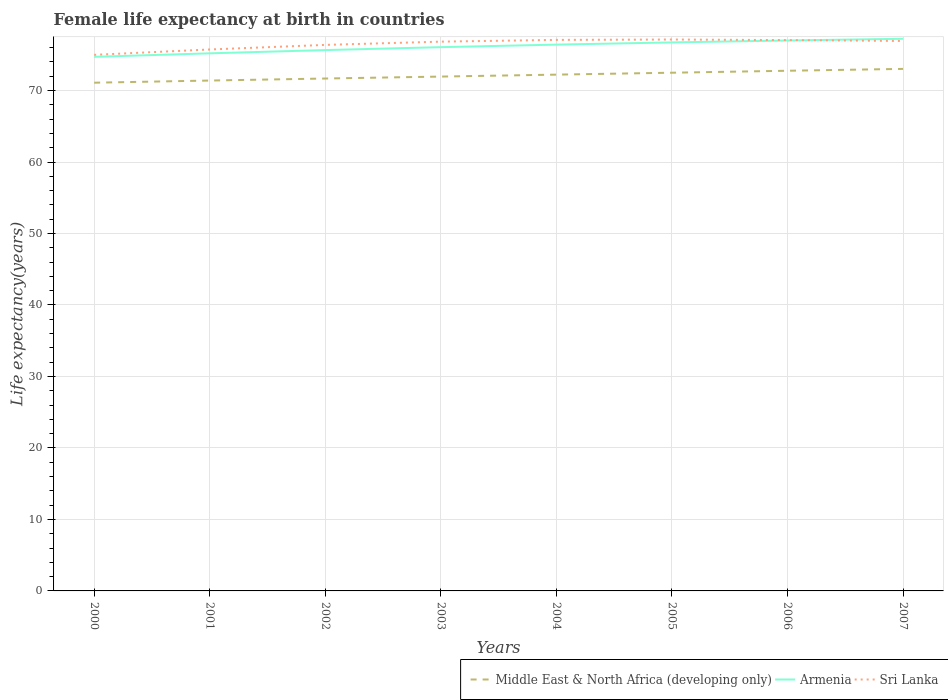How many different coloured lines are there?
Make the answer very short. 3. Does the line corresponding to Sri Lanka intersect with the line corresponding to Armenia?
Your answer should be very brief. Yes. Is the number of lines equal to the number of legend labels?
Give a very brief answer. Yes. Across all years, what is the maximum female life expectancy at birth in Sri Lanka?
Your response must be concise. 75. In which year was the female life expectancy at birth in Middle East & North Africa (developing only) maximum?
Your answer should be very brief. 2000. What is the total female life expectancy at birth in Armenia in the graph?
Make the answer very short. -0.57. What is the difference between the highest and the second highest female life expectancy at birth in Sri Lanka?
Make the answer very short. 2.14. What is the difference between the highest and the lowest female life expectancy at birth in Armenia?
Provide a short and direct response. 4. How many years are there in the graph?
Your response must be concise. 8. Are the values on the major ticks of Y-axis written in scientific E-notation?
Provide a short and direct response. No. Does the graph contain any zero values?
Provide a short and direct response. No. Does the graph contain grids?
Offer a terse response. Yes. How many legend labels are there?
Provide a succinct answer. 3. What is the title of the graph?
Keep it short and to the point. Female life expectancy at birth in countries. What is the label or title of the X-axis?
Ensure brevity in your answer.  Years. What is the label or title of the Y-axis?
Give a very brief answer. Life expectancy(years). What is the Life expectancy(years) of Middle East & North Africa (developing only) in 2000?
Offer a very short reply. 71.1. What is the Life expectancy(years) in Armenia in 2000?
Your response must be concise. 74.72. What is the Life expectancy(years) in Sri Lanka in 2000?
Offer a very short reply. 75. What is the Life expectancy(years) of Middle East & North Africa (developing only) in 2001?
Your answer should be compact. 71.4. What is the Life expectancy(years) in Armenia in 2001?
Your answer should be compact. 75.21. What is the Life expectancy(years) in Sri Lanka in 2001?
Provide a succinct answer. 75.75. What is the Life expectancy(years) of Middle East & North Africa (developing only) in 2002?
Ensure brevity in your answer.  71.68. What is the Life expectancy(years) of Armenia in 2002?
Offer a terse response. 75.66. What is the Life expectancy(years) in Sri Lanka in 2002?
Your response must be concise. 76.39. What is the Life expectancy(years) in Middle East & North Africa (developing only) in 2003?
Make the answer very short. 71.96. What is the Life expectancy(years) of Armenia in 2003?
Provide a short and direct response. 76.07. What is the Life expectancy(years) in Sri Lanka in 2003?
Provide a succinct answer. 76.84. What is the Life expectancy(years) of Middle East & North Africa (developing only) in 2004?
Your answer should be very brief. 72.23. What is the Life expectancy(years) in Armenia in 2004?
Make the answer very short. 76.43. What is the Life expectancy(years) in Sri Lanka in 2004?
Ensure brevity in your answer.  77.09. What is the Life expectancy(years) of Middle East & North Africa (developing only) in 2005?
Ensure brevity in your answer.  72.5. What is the Life expectancy(years) of Armenia in 2005?
Your response must be concise. 76.74. What is the Life expectancy(years) of Sri Lanka in 2005?
Your response must be concise. 77.14. What is the Life expectancy(years) in Middle East & North Africa (developing only) in 2006?
Your answer should be compact. 72.77. What is the Life expectancy(years) of Armenia in 2006?
Offer a very short reply. 77. What is the Life expectancy(years) in Sri Lanka in 2006?
Offer a very short reply. 77.06. What is the Life expectancy(years) in Middle East & North Africa (developing only) in 2007?
Your answer should be compact. 73.03. What is the Life expectancy(years) in Armenia in 2007?
Offer a very short reply. 77.24. What is the Life expectancy(years) of Sri Lanka in 2007?
Your response must be concise. 76.94. Across all years, what is the maximum Life expectancy(years) in Middle East & North Africa (developing only)?
Provide a succinct answer. 73.03. Across all years, what is the maximum Life expectancy(years) in Armenia?
Your answer should be compact. 77.24. Across all years, what is the maximum Life expectancy(years) of Sri Lanka?
Your answer should be very brief. 77.14. Across all years, what is the minimum Life expectancy(years) in Middle East & North Africa (developing only)?
Provide a succinct answer. 71.1. Across all years, what is the minimum Life expectancy(years) of Armenia?
Your response must be concise. 74.72. Across all years, what is the minimum Life expectancy(years) of Sri Lanka?
Make the answer very short. 75. What is the total Life expectancy(years) in Middle East & North Africa (developing only) in the graph?
Ensure brevity in your answer.  576.66. What is the total Life expectancy(years) of Armenia in the graph?
Your response must be concise. 609.07. What is the total Life expectancy(years) of Sri Lanka in the graph?
Provide a succinct answer. 612.19. What is the difference between the Life expectancy(years) of Middle East & North Africa (developing only) in 2000 and that in 2001?
Offer a terse response. -0.3. What is the difference between the Life expectancy(years) in Armenia in 2000 and that in 2001?
Your answer should be very brief. -0.49. What is the difference between the Life expectancy(years) of Sri Lanka in 2000 and that in 2001?
Make the answer very short. -0.75. What is the difference between the Life expectancy(years) in Middle East & North Africa (developing only) in 2000 and that in 2002?
Your answer should be compact. -0.59. What is the difference between the Life expectancy(years) of Armenia in 2000 and that in 2002?
Give a very brief answer. -0.94. What is the difference between the Life expectancy(years) of Sri Lanka in 2000 and that in 2002?
Offer a very short reply. -1.39. What is the difference between the Life expectancy(years) of Middle East & North Africa (developing only) in 2000 and that in 2003?
Provide a short and direct response. -0.86. What is the difference between the Life expectancy(years) of Armenia in 2000 and that in 2003?
Your response must be concise. -1.35. What is the difference between the Life expectancy(years) in Sri Lanka in 2000 and that in 2003?
Your response must be concise. -1.85. What is the difference between the Life expectancy(years) in Middle East & North Africa (developing only) in 2000 and that in 2004?
Offer a very short reply. -1.13. What is the difference between the Life expectancy(years) of Armenia in 2000 and that in 2004?
Provide a short and direct response. -1.71. What is the difference between the Life expectancy(years) in Sri Lanka in 2000 and that in 2004?
Keep it short and to the point. -2.09. What is the difference between the Life expectancy(years) of Middle East & North Africa (developing only) in 2000 and that in 2005?
Make the answer very short. -1.4. What is the difference between the Life expectancy(years) of Armenia in 2000 and that in 2005?
Give a very brief answer. -2.02. What is the difference between the Life expectancy(years) of Sri Lanka in 2000 and that in 2005?
Your answer should be compact. -2.15. What is the difference between the Life expectancy(years) in Middle East & North Africa (developing only) in 2000 and that in 2006?
Your answer should be compact. -1.67. What is the difference between the Life expectancy(years) of Armenia in 2000 and that in 2006?
Offer a terse response. -2.29. What is the difference between the Life expectancy(years) of Sri Lanka in 2000 and that in 2006?
Provide a short and direct response. -2.06. What is the difference between the Life expectancy(years) of Middle East & North Africa (developing only) in 2000 and that in 2007?
Your answer should be very brief. -1.93. What is the difference between the Life expectancy(years) in Armenia in 2000 and that in 2007?
Offer a terse response. -2.53. What is the difference between the Life expectancy(years) of Sri Lanka in 2000 and that in 2007?
Ensure brevity in your answer.  -1.94. What is the difference between the Life expectancy(years) in Middle East & North Africa (developing only) in 2001 and that in 2002?
Give a very brief answer. -0.28. What is the difference between the Life expectancy(years) of Armenia in 2001 and that in 2002?
Keep it short and to the point. -0.46. What is the difference between the Life expectancy(years) of Sri Lanka in 2001 and that in 2002?
Provide a succinct answer. -0.64. What is the difference between the Life expectancy(years) of Middle East & North Africa (developing only) in 2001 and that in 2003?
Ensure brevity in your answer.  -0.56. What is the difference between the Life expectancy(years) in Armenia in 2001 and that in 2003?
Ensure brevity in your answer.  -0.86. What is the difference between the Life expectancy(years) in Sri Lanka in 2001 and that in 2003?
Your response must be concise. -1.1. What is the difference between the Life expectancy(years) of Middle East & North Africa (developing only) in 2001 and that in 2004?
Make the answer very short. -0.83. What is the difference between the Life expectancy(years) of Armenia in 2001 and that in 2004?
Provide a short and direct response. -1.22. What is the difference between the Life expectancy(years) of Sri Lanka in 2001 and that in 2004?
Your answer should be very brief. -1.34. What is the difference between the Life expectancy(years) of Middle East & North Africa (developing only) in 2001 and that in 2005?
Provide a short and direct response. -1.1. What is the difference between the Life expectancy(years) of Armenia in 2001 and that in 2005?
Keep it short and to the point. -1.53. What is the difference between the Life expectancy(years) in Sri Lanka in 2001 and that in 2005?
Your answer should be very brief. -1.39. What is the difference between the Life expectancy(years) in Middle East & North Africa (developing only) in 2001 and that in 2006?
Make the answer very short. -1.37. What is the difference between the Life expectancy(years) of Armenia in 2001 and that in 2006?
Offer a terse response. -1.79. What is the difference between the Life expectancy(years) of Sri Lanka in 2001 and that in 2006?
Your response must be concise. -1.31. What is the difference between the Life expectancy(years) of Middle East & North Africa (developing only) in 2001 and that in 2007?
Ensure brevity in your answer.  -1.63. What is the difference between the Life expectancy(years) in Armenia in 2001 and that in 2007?
Ensure brevity in your answer.  -2.04. What is the difference between the Life expectancy(years) of Sri Lanka in 2001 and that in 2007?
Provide a short and direct response. -1.19. What is the difference between the Life expectancy(years) of Middle East & North Africa (developing only) in 2002 and that in 2003?
Ensure brevity in your answer.  -0.27. What is the difference between the Life expectancy(years) of Armenia in 2002 and that in 2003?
Offer a very short reply. -0.41. What is the difference between the Life expectancy(years) in Sri Lanka in 2002 and that in 2003?
Keep it short and to the point. -0.46. What is the difference between the Life expectancy(years) of Middle East & North Africa (developing only) in 2002 and that in 2004?
Your response must be concise. -0.54. What is the difference between the Life expectancy(years) in Armenia in 2002 and that in 2004?
Your response must be concise. -0.77. What is the difference between the Life expectancy(years) of Sri Lanka in 2002 and that in 2004?
Your answer should be compact. -0.7. What is the difference between the Life expectancy(years) in Middle East & North Africa (developing only) in 2002 and that in 2005?
Keep it short and to the point. -0.81. What is the difference between the Life expectancy(years) in Armenia in 2002 and that in 2005?
Make the answer very short. -1.07. What is the difference between the Life expectancy(years) in Sri Lanka in 2002 and that in 2005?
Your response must be concise. -0.75. What is the difference between the Life expectancy(years) of Middle East & North Africa (developing only) in 2002 and that in 2006?
Offer a terse response. -1.09. What is the difference between the Life expectancy(years) in Armenia in 2002 and that in 2006?
Your response must be concise. -1.34. What is the difference between the Life expectancy(years) of Sri Lanka in 2002 and that in 2006?
Make the answer very short. -0.67. What is the difference between the Life expectancy(years) in Middle East & North Africa (developing only) in 2002 and that in 2007?
Offer a very short reply. -1.35. What is the difference between the Life expectancy(years) in Armenia in 2002 and that in 2007?
Your response must be concise. -1.58. What is the difference between the Life expectancy(years) in Sri Lanka in 2002 and that in 2007?
Offer a very short reply. -0.55. What is the difference between the Life expectancy(years) of Middle East & North Africa (developing only) in 2003 and that in 2004?
Keep it short and to the point. -0.27. What is the difference between the Life expectancy(years) in Armenia in 2003 and that in 2004?
Make the answer very short. -0.36. What is the difference between the Life expectancy(years) in Sri Lanka in 2003 and that in 2004?
Keep it short and to the point. -0.24. What is the difference between the Life expectancy(years) of Middle East & North Africa (developing only) in 2003 and that in 2005?
Your answer should be compact. -0.54. What is the difference between the Life expectancy(years) of Armenia in 2003 and that in 2005?
Make the answer very short. -0.67. What is the difference between the Life expectancy(years) in Sri Lanka in 2003 and that in 2005?
Make the answer very short. -0.3. What is the difference between the Life expectancy(years) of Middle East & North Africa (developing only) in 2003 and that in 2006?
Offer a very short reply. -0.81. What is the difference between the Life expectancy(years) of Armenia in 2003 and that in 2006?
Provide a short and direct response. -0.93. What is the difference between the Life expectancy(years) in Sri Lanka in 2003 and that in 2006?
Your response must be concise. -0.21. What is the difference between the Life expectancy(years) in Middle East & North Africa (developing only) in 2003 and that in 2007?
Make the answer very short. -1.08. What is the difference between the Life expectancy(years) of Armenia in 2003 and that in 2007?
Give a very brief answer. -1.17. What is the difference between the Life expectancy(years) of Sri Lanka in 2003 and that in 2007?
Keep it short and to the point. -0.09. What is the difference between the Life expectancy(years) of Middle East & North Africa (developing only) in 2004 and that in 2005?
Keep it short and to the point. -0.27. What is the difference between the Life expectancy(years) in Armenia in 2004 and that in 2005?
Ensure brevity in your answer.  -0.31. What is the difference between the Life expectancy(years) in Sri Lanka in 2004 and that in 2005?
Your answer should be compact. -0.05. What is the difference between the Life expectancy(years) of Middle East & North Africa (developing only) in 2004 and that in 2006?
Your answer should be compact. -0.54. What is the difference between the Life expectancy(years) of Armenia in 2004 and that in 2006?
Offer a terse response. -0.57. What is the difference between the Life expectancy(years) in Sri Lanka in 2004 and that in 2006?
Keep it short and to the point. 0.03. What is the difference between the Life expectancy(years) of Middle East & North Africa (developing only) in 2004 and that in 2007?
Provide a succinct answer. -0.8. What is the difference between the Life expectancy(years) in Armenia in 2004 and that in 2007?
Provide a succinct answer. -0.82. What is the difference between the Life expectancy(years) of Middle East & North Africa (developing only) in 2005 and that in 2006?
Offer a terse response. -0.27. What is the difference between the Life expectancy(years) of Armenia in 2005 and that in 2006?
Provide a succinct answer. -0.27. What is the difference between the Life expectancy(years) of Sri Lanka in 2005 and that in 2006?
Provide a short and direct response. 0.08. What is the difference between the Life expectancy(years) in Middle East & North Africa (developing only) in 2005 and that in 2007?
Your response must be concise. -0.54. What is the difference between the Life expectancy(years) of Armenia in 2005 and that in 2007?
Give a very brief answer. -0.51. What is the difference between the Life expectancy(years) of Sri Lanka in 2005 and that in 2007?
Make the answer very short. 0.2. What is the difference between the Life expectancy(years) of Middle East & North Africa (developing only) in 2006 and that in 2007?
Provide a short and direct response. -0.26. What is the difference between the Life expectancy(years) in Armenia in 2006 and that in 2007?
Your answer should be compact. -0.24. What is the difference between the Life expectancy(years) in Sri Lanka in 2006 and that in 2007?
Your response must be concise. 0.12. What is the difference between the Life expectancy(years) in Middle East & North Africa (developing only) in 2000 and the Life expectancy(years) in Armenia in 2001?
Provide a succinct answer. -4.11. What is the difference between the Life expectancy(years) of Middle East & North Africa (developing only) in 2000 and the Life expectancy(years) of Sri Lanka in 2001?
Your answer should be very brief. -4.65. What is the difference between the Life expectancy(years) of Armenia in 2000 and the Life expectancy(years) of Sri Lanka in 2001?
Ensure brevity in your answer.  -1.03. What is the difference between the Life expectancy(years) in Middle East & North Africa (developing only) in 2000 and the Life expectancy(years) in Armenia in 2002?
Ensure brevity in your answer.  -4.56. What is the difference between the Life expectancy(years) in Middle East & North Africa (developing only) in 2000 and the Life expectancy(years) in Sri Lanka in 2002?
Offer a very short reply. -5.29. What is the difference between the Life expectancy(years) in Armenia in 2000 and the Life expectancy(years) in Sri Lanka in 2002?
Give a very brief answer. -1.67. What is the difference between the Life expectancy(years) of Middle East & North Africa (developing only) in 2000 and the Life expectancy(years) of Armenia in 2003?
Offer a terse response. -4.97. What is the difference between the Life expectancy(years) of Middle East & North Africa (developing only) in 2000 and the Life expectancy(years) of Sri Lanka in 2003?
Your response must be concise. -5.74. What is the difference between the Life expectancy(years) in Armenia in 2000 and the Life expectancy(years) in Sri Lanka in 2003?
Provide a short and direct response. -2.13. What is the difference between the Life expectancy(years) of Middle East & North Africa (developing only) in 2000 and the Life expectancy(years) of Armenia in 2004?
Make the answer very short. -5.33. What is the difference between the Life expectancy(years) in Middle East & North Africa (developing only) in 2000 and the Life expectancy(years) in Sri Lanka in 2004?
Offer a very short reply. -5.99. What is the difference between the Life expectancy(years) of Armenia in 2000 and the Life expectancy(years) of Sri Lanka in 2004?
Your answer should be very brief. -2.37. What is the difference between the Life expectancy(years) of Middle East & North Africa (developing only) in 2000 and the Life expectancy(years) of Armenia in 2005?
Your answer should be very brief. -5.64. What is the difference between the Life expectancy(years) of Middle East & North Africa (developing only) in 2000 and the Life expectancy(years) of Sri Lanka in 2005?
Your answer should be compact. -6.04. What is the difference between the Life expectancy(years) of Armenia in 2000 and the Life expectancy(years) of Sri Lanka in 2005?
Keep it short and to the point. -2.42. What is the difference between the Life expectancy(years) in Middle East & North Africa (developing only) in 2000 and the Life expectancy(years) in Armenia in 2006?
Provide a succinct answer. -5.9. What is the difference between the Life expectancy(years) of Middle East & North Africa (developing only) in 2000 and the Life expectancy(years) of Sri Lanka in 2006?
Make the answer very short. -5.96. What is the difference between the Life expectancy(years) in Armenia in 2000 and the Life expectancy(years) in Sri Lanka in 2006?
Provide a succinct answer. -2.34. What is the difference between the Life expectancy(years) of Middle East & North Africa (developing only) in 2000 and the Life expectancy(years) of Armenia in 2007?
Keep it short and to the point. -6.14. What is the difference between the Life expectancy(years) of Middle East & North Africa (developing only) in 2000 and the Life expectancy(years) of Sri Lanka in 2007?
Offer a terse response. -5.84. What is the difference between the Life expectancy(years) of Armenia in 2000 and the Life expectancy(years) of Sri Lanka in 2007?
Give a very brief answer. -2.22. What is the difference between the Life expectancy(years) of Middle East & North Africa (developing only) in 2001 and the Life expectancy(years) of Armenia in 2002?
Give a very brief answer. -4.26. What is the difference between the Life expectancy(years) in Middle East & North Africa (developing only) in 2001 and the Life expectancy(years) in Sri Lanka in 2002?
Your response must be concise. -4.99. What is the difference between the Life expectancy(years) of Armenia in 2001 and the Life expectancy(years) of Sri Lanka in 2002?
Your answer should be compact. -1.18. What is the difference between the Life expectancy(years) of Middle East & North Africa (developing only) in 2001 and the Life expectancy(years) of Armenia in 2003?
Offer a very short reply. -4.67. What is the difference between the Life expectancy(years) in Middle East & North Africa (developing only) in 2001 and the Life expectancy(years) in Sri Lanka in 2003?
Provide a succinct answer. -5.44. What is the difference between the Life expectancy(years) of Armenia in 2001 and the Life expectancy(years) of Sri Lanka in 2003?
Your answer should be very brief. -1.64. What is the difference between the Life expectancy(years) in Middle East & North Africa (developing only) in 2001 and the Life expectancy(years) in Armenia in 2004?
Your answer should be compact. -5.03. What is the difference between the Life expectancy(years) in Middle East & North Africa (developing only) in 2001 and the Life expectancy(years) in Sri Lanka in 2004?
Your answer should be compact. -5.69. What is the difference between the Life expectancy(years) in Armenia in 2001 and the Life expectancy(years) in Sri Lanka in 2004?
Provide a succinct answer. -1.88. What is the difference between the Life expectancy(years) in Middle East & North Africa (developing only) in 2001 and the Life expectancy(years) in Armenia in 2005?
Your answer should be very brief. -5.34. What is the difference between the Life expectancy(years) in Middle East & North Africa (developing only) in 2001 and the Life expectancy(years) in Sri Lanka in 2005?
Your answer should be very brief. -5.74. What is the difference between the Life expectancy(years) in Armenia in 2001 and the Life expectancy(years) in Sri Lanka in 2005?
Provide a succinct answer. -1.93. What is the difference between the Life expectancy(years) of Middle East & North Africa (developing only) in 2001 and the Life expectancy(years) of Armenia in 2006?
Offer a very short reply. -5.6. What is the difference between the Life expectancy(years) in Middle East & North Africa (developing only) in 2001 and the Life expectancy(years) in Sri Lanka in 2006?
Ensure brevity in your answer.  -5.66. What is the difference between the Life expectancy(years) in Armenia in 2001 and the Life expectancy(years) in Sri Lanka in 2006?
Offer a very short reply. -1.85. What is the difference between the Life expectancy(years) in Middle East & North Africa (developing only) in 2001 and the Life expectancy(years) in Armenia in 2007?
Offer a very short reply. -5.84. What is the difference between the Life expectancy(years) of Middle East & North Africa (developing only) in 2001 and the Life expectancy(years) of Sri Lanka in 2007?
Give a very brief answer. -5.54. What is the difference between the Life expectancy(years) in Armenia in 2001 and the Life expectancy(years) in Sri Lanka in 2007?
Make the answer very short. -1.73. What is the difference between the Life expectancy(years) of Middle East & North Africa (developing only) in 2002 and the Life expectancy(years) of Armenia in 2003?
Ensure brevity in your answer.  -4.39. What is the difference between the Life expectancy(years) of Middle East & North Africa (developing only) in 2002 and the Life expectancy(years) of Sri Lanka in 2003?
Your answer should be compact. -5.16. What is the difference between the Life expectancy(years) in Armenia in 2002 and the Life expectancy(years) in Sri Lanka in 2003?
Make the answer very short. -1.18. What is the difference between the Life expectancy(years) of Middle East & North Africa (developing only) in 2002 and the Life expectancy(years) of Armenia in 2004?
Your response must be concise. -4.74. What is the difference between the Life expectancy(years) in Middle East & North Africa (developing only) in 2002 and the Life expectancy(years) in Sri Lanka in 2004?
Give a very brief answer. -5.4. What is the difference between the Life expectancy(years) of Armenia in 2002 and the Life expectancy(years) of Sri Lanka in 2004?
Your answer should be compact. -1.43. What is the difference between the Life expectancy(years) in Middle East & North Africa (developing only) in 2002 and the Life expectancy(years) in Armenia in 2005?
Your response must be concise. -5.05. What is the difference between the Life expectancy(years) of Middle East & North Africa (developing only) in 2002 and the Life expectancy(years) of Sri Lanka in 2005?
Offer a very short reply. -5.46. What is the difference between the Life expectancy(years) in Armenia in 2002 and the Life expectancy(years) in Sri Lanka in 2005?
Give a very brief answer. -1.48. What is the difference between the Life expectancy(years) in Middle East & North Africa (developing only) in 2002 and the Life expectancy(years) in Armenia in 2006?
Give a very brief answer. -5.32. What is the difference between the Life expectancy(years) in Middle East & North Africa (developing only) in 2002 and the Life expectancy(years) in Sri Lanka in 2006?
Keep it short and to the point. -5.37. What is the difference between the Life expectancy(years) in Armenia in 2002 and the Life expectancy(years) in Sri Lanka in 2006?
Your response must be concise. -1.4. What is the difference between the Life expectancy(years) in Middle East & North Africa (developing only) in 2002 and the Life expectancy(years) in Armenia in 2007?
Give a very brief answer. -5.56. What is the difference between the Life expectancy(years) of Middle East & North Africa (developing only) in 2002 and the Life expectancy(years) of Sri Lanka in 2007?
Provide a succinct answer. -5.25. What is the difference between the Life expectancy(years) in Armenia in 2002 and the Life expectancy(years) in Sri Lanka in 2007?
Your answer should be compact. -1.27. What is the difference between the Life expectancy(years) of Middle East & North Africa (developing only) in 2003 and the Life expectancy(years) of Armenia in 2004?
Keep it short and to the point. -4.47. What is the difference between the Life expectancy(years) of Middle East & North Africa (developing only) in 2003 and the Life expectancy(years) of Sri Lanka in 2004?
Offer a terse response. -5.13. What is the difference between the Life expectancy(years) in Armenia in 2003 and the Life expectancy(years) in Sri Lanka in 2004?
Your answer should be very brief. -1.02. What is the difference between the Life expectancy(years) in Middle East & North Africa (developing only) in 2003 and the Life expectancy(years) in Armenia in 2005?
Your answer should be very brief. -4.78. What is the difference between the Life expectancy(years) of Middle East & North Africa (developing only) in 2003 and the Life expectancy(years) of Sri Lanka in 2005?
Your answer should be compact. -5.18. What is the difference between the Life expectancy(years) in Armenia in 2003 and the Life expectancy(years) in Sri Lanka in 2005?
Provide a succinct answer. -1.07. What is the difference between the Life expectancy(years) in Middle East & North Africa (developing only) in 2003 and the Life expectancy(years) in Armenia in 2006?
Offer a very short reply. -5.05. What is the difference between the Life expectancy(years) in Middle East & North Africa (developing only) in 2003 and the Life expectancy(years) in Sri Lanka in 2006?
Your response must be concise. -5.1. What is the difference between the Life expectancy(years) of Armenia in 2003 and the Life expectancy(years) of Sri Lanka in 2006?
Ensure brevity in your answer.  -0.99. What is the difference between the Life expectancy(years) in Middle East & North Africa (developing only) in 2003 and the Life expectancy(years) in Armenia in 2007?
Your answer should be very brief. -5.29. What is the difference between the Life expectancy(years) in Middle East & North Africa (developing only) in 2003 and the Life expectancy(years) in Sri Lanka in 2007?
Your response must be concise. -4.98. What is the difference between the Life expectancy(years) of Armenia in 2003 and the Life expectancy(years) of Sri Lanka in 2007?
Your answer should be very brief. -0.87. What is the difference between the Life expectancy(years) in Middle East & North Africa (developing only) in 2004 and the Life expectancy(years) in Armenia in 2005?
Your response must be concise. -4.51. What is the difference between the Life expectancy(years) of Middle East & North Africa (developing only) in 2004 and the Life expectancy(years) of Sri Lanka in 2005?
Provide a succinct answer. -4.91. What is the difference between the Life expectancy(years) in Armenia in 2004 and the Life expectancy(years) in Sri Lanka in 2005?
Give a very brief answer. -0.71. What is the difference between the Life expectancy(years) of Middle East & North Africa (developing only) in 2004 and the Life expectancy(years) of Armenia in 2006?
Provide a succinct answer. -4.77. What is the difference between the Life expectancy(years) of Middle East & North Africa (developing only) in 2004 and the Life expectancy(years) of Sri Lanka in 2006?
Your answer should be compact. -4.83. What is the difference between the Life expectancy(years) of Armenia in 2004 and the Life expectancy(years) of Sri Lanka in 2006?
Make the answer very short. -0.63. What is the difference between the Life expectancy(years) of Middle East & North Africa (developing only) in 2004 and the Life expectancy(years) of Armenia in 2007?
Give a very brief answer. -5.02. What is the difference between the Life expectancy(years) of Middle East & North Africa (developing only) in 2004 and the Life expectancy(years) of Sri Lanka in 2007?
Your answer should be compact. -4.71. What is the difference between the Life expectancy(years) in Armenia in 2004 and the Life expectancy(years) in Sri Lanka in 2007?
Give a very brief answer. -0.51. What is the difference between the Life expectancy(years) of Middle East & North Africa (developing only) in 2005 and the Life expectancy(years) of Armenia in 2006?
Your answer should be very brief. -4.51. What is the difference between the Life expectancy(years) in Middle East & North Africa (developing only) in 2005 and the Life expectancy(years) in Sri Lanka in 2006?
Ensure brevity in your answer.  -4.56. What is the difference between the Life expectancy(years) of Armenia in 2005 and the Life expectancy(years) of Sri Lanka in 2006?
Make the answer very short. -0.32. What is the difference between the Life expectancy(years) in Middle East & North Africa (developing only) in 2005 and the Life expectancy(years) in Armenia in 2007?
Your answer should be compact. -4.75. What is the difference between the Life expectancy(years) in Middle East & North Africa (developing only) in 2005 and the Life expectancy(years) in Sri Lanka in 2007?
Offer a terse response. -4.44. What is the difference between the Life expectancy(years) of Armenia in 2005 and the Life expectancy(years) of Sri Lanka in 2007?
Give a very brief answer. -0.2. What is the difference between the Life expectancy(years) in Middle East & North Africa (developing only) in 2006 and the Life expectancy(years) in Armenia in 2007?
Offer a very short reply. -4.47. What is the difference between the Life expectancy(years) in Middle East & North Africa (developing only) in 2006 and the Life expectancy(years) in Sri Lanka in 2007?
Ensure brevity in your answer.  -4.17. What is the difference between the Life expectancy(years) in Armenia in 2006 and the Life expectancy(years) in Sri Lanka in 2007?
Ensure brevity in your answer.  0.07. What is the average Life expectancy(years) in Middle East & North Africa (developing only) per year?
Ensure brevity in your answer.  72.08. What is the average Life expectancy(years) in Armenia per year?
Provide a short and direct response. 76.13. What is the average Life expectancy(years) of Sri Lanka per year?
Provide a succinct answer. 76.52. In the year 2000, what is the difference between the Life expectancy(years) in Middle East & North Africa (developing only) and Life expectancy(years) in Armenia?
Give a very brief answer. -3.62. In the year 2000, what is the difference between the Life expectancy(years) of Middle East & North Africa (developing only) and Life expectancy(years) of Sri Lanka?
Give a very brief answer. -3.9. In the year 2000, what is the difference between the Life expectancy(years) of Armenia and Life expectancy(years) of Sri Lanka?
Offer a very short reply. -0.28. In the year 2001, what is the difference between the Life expectancy(years) in Middle East & North Africa (developing only) and Life expectancy(years) in Armenia?
Ensure brevity in your answer.  -3.81. In the year 2001, what is the difference between the Life expectancy(years) of Middle East & North Africa (developing only) and Life expectancy(years) of Sri Lanka?
Ensure brevity in your answer.  -4.35. In the year 2001, what is the difference between the Life expectancy(years) of Armenia and Life expectancy(years) of Sri Lanka?
Keep it short and to the point. -0.54. In the year 2002, what is the difference between the Life expectancy(years) in Middle East & North Africa (developing only) and Life expectancy(years) in Armenia?
Your answer should be very brief. -3.98. In the year 2002, what is the difference between the Life expectancy(years) of Middle East & North Africa (developing only) and Life expectancy(years) of Sri Lanka?
Ensure brevity in your answer.  -4.7. In the year 2002, what is the difference between the Life expectancy(years) in Armenia and Life expectancy(years) in Sri Lanka?
Keep it short and to the point. -0.73. In the year 2003, what is the difference between the Life expectancy(years) in Middle East & North Africa (developing only) and Life expectancy(years) in Armenia?
Offer a very short reply. -4.12. In the year 2003, what is the difference between the Life expectancy(years) of Middle East & North Africa (developing only) and Life expectancy(years) of Sri Lanka?
Ensure brevity in your answer.  -4.89. In the year 2003, what is the difference between the Life expectancy(years) of Armenia and Life expectancy(years) of Sri Lanka?
Give a very brief answer. -0.77. In the year 2004, what is the difference between the Life expectancy(years) in Middle East & North Africa (developing only) and Life expectancy(years) in Armenia?
Provide a short and direct response. -4.2. In the year 2004, what is the difference between the Life expectancy(years) in Middle East & North Africa (developing only) and Life expectancy(years) in Sri Lanka?
Offer a very short reply. -4.86. In the year 2004, what is the difference between the Life expectancy(years) in Armenia and Life expectancy(years) in Sri Lanka?
Give a very brief answer. -0.66. In the year 2005, what is the difference between the Life expectancy(years) in Middle East & North Africa (developing only) and Life expectancy(years) in Armenia?
Your response must be concise. -4.24. In the year 2005, what is the difference between the Life expectancy(years) of Middle East & North Africa (developing only) and Life expectancy(years) of Sri Lanka?
Ensure brevity in your answer.  -4.64. In the year 2005, what is the difference between the Life expectancy(years) in Armenia and Life expectancy(years) in Sri Lanka?
Offer a terse response. -0.4. In the year 2006, what is the difference between the Life expectancy(years) in Middle East & North Africa (developing only) and Life expectancy(years) in Armenia?
Make the answer very short. -4.23. In the year 2006, what is the difference between the Life expectancy(years) in Middle East & North Africa (developing only) and Life expectancy(years) in Sri Lanka?
Offer a terse response. -4.29. In the year 2006, what is the difference between the Life expectancy(years) of Armenia and Life expectancy(years) of Sri Lanka?
Your answer should be very brief. -0.06. In the year 2007, what is the difference between the Life expectancy(years) of Middle East & North Africa (developing only) and Life expectancy(years) of Armenia?
Offer a terse response. -4.21. In the year 2007, what is the difference between the Life expectancy(years) in Middle East & North Africa (developing only) and Life expectancy(years) in Sri Lanka?
Ensure brevity in your answer.  -3.91. In the year 2007, what is the difference between the Life expectancy(years) in Armenia and Life expectancy(years) in Sri Lanka?
Provide a short and direct response. 0.31. What is the ratio of the Life expectancy(years) in Middle East & North Africa (developing only) in 2000 to that in 2001?
Offer a very short reply. 1. What is the ratio of the Life expectancy(years) in Armenia in 2000 to that in 2001?
Your answer should be compact. 0.99. What is the ratio of the Life expectancy(years) in Armenia in 2000 to that in 2002?
Your answer should be compact. 0.99. What is the ratio of the Life expectancy(years) of Sri Lanka in 2000 to that in 2002?
Provide a short and direct response. 0.98. What is the ratio of the Life expectancy(years) in Armenia in 2000 to that in 2003?
Your response must be concise. 0.98. What is the ratio of the Life expectancy(years) of Sri Lanka in 2000 to that in 2003?
Keep it short and to the point. 0.98. What is the ratio of the Life expectancy(years) in Middle East & North Africa (developing only) in 2000 to that in 2004?
Offer a very short reply. 0.98. What is the ratio of the Life expectancy(years) in Armenia in 2000 to that in 2004?
Your answer should be compact. 0.98. What is the ratio of the Life expectancy(years) of Sri Lanka in 2000 to that in 2004?
Give a very brief answer. 0.97. What is the ratio of the Life expectancy(years) of Middle East & North Africa (developing only) in 2000 to that in 2005?
Your response must be concise. 0.98. What is the ratio of the Life expectancy(years) of Armenia in 2000 to that in 2005?
Offer a very short reply. 0.97. What is the ratio of the Life expectancy(years) of Sri Lanka in 2000 to that in 2005?
Offer a terse response. 0.97. What is the ratio of the Life expectancy(years) in Middle East & North Africa (developing only) in 2000 to that in 2006?
Give a very brief answer. 0.98. What is the ratio of the Life expectancy(years) of Armenia in 2000 to that in 2006?
Make the answer very short. 0.97. What is the ratio of the Life expectancy(years) in Sri Lanka in 2000 to that in 2006?
Your response must be concise. 0.97. What is the ratio of the Life expectancy(years) in Middle East & North Africa (developing only) in 2000 to that in 2007?
Offer a very short reply. 0.97. What is the ratio of the Life expectancy(years) in Armenia in 2000 to that in 2007?
Provide a short and direct response. 0.97. What is the ratio of the Life expectancy(years) in Sri Lanka in 2000 to that in 2007?
Your answer should be very brief. 0.97. What is the ratio of the Life expectancy(years) of Middle East & North Africa (developing only) in 2001 to that in 2003?
Your answer should be compact. 0.99. What is the ratio of the Life expectancy(years) of Sri Lanka in 2001 to that in 2003?
Ensure brevity in your answer.  0.99. What is the ratio of the Life expectancy(years) of Armenia in 2001 to that in 2004?
Make the answer very short. 0.98. What is the ratio of the Life expectancy(years) of Sri Lanka in 2001 to that in 2004?
Give a very brief answer. 0.98. What is the ratio of the Life expectancy(years) of Middle East & North Africa (developing only) in 2001 to that in 2005?
Offer a very short reply. 0.98. What is the ratio of the Life expectancy(years) of Armenia in 2001 to that in 2005?
Offer a terse response. 0.98. What is the ratio of the Life expectancy(years) in Sri Lanka in 2001 to that in 2005?
Your answer should be compact. 0.98. What is the ratio of the Life expectancy(years) of Middle East & North Africa (developing only) in 2001 to that in 2006?
Provide a succinct answer. 0.98. What is the ratio of the Life expectancy(years) of Armenia in 2001 to that in 2006?
Ensure brevity in your answer.  0.98. What is the ratio of the Life expectancy(years) in Middle East & North Africa (developing only) in 2001 to that in 2007?
Provide a short and direct response. 0.98. What is the ratio of the Life expectancy(years) of Armenia in 2001 to that in 2007?
Make the answer very short. 0.97. What is the ratio of the Life expectancy(years) of Sri Lanka in 2001 to that in 2007?
Provide a succinct answer. 0.98. What is the ratio of the Life expectancy(years) of Armenia in 2002 to that in 2003?
Give a very brief answer. 0.99. What is the ratio of the Life expectancy(years) of Middle East & North Africa (developing only) in 2002 to that in 2004?
Give a very brief answer. 0.99. What is the ratio of the Life expectancy(years) in Sri Lanka in 2002 to that in 2004?
Offer a very short reply. 0.99. What is the ratio of the Life expectancy(years) of Middle East & North Africa (developing only) in 2002 to that in 2005?
Keep it short and to the point. 0.99. What is the ratio of the Life expectancy(years) of Sri Lanka in 2002 to that in 2005?
Your answer should be compact. 0.99. What is the ratio of the Life expectancy(years) in Middle East & North Africa (developing only) in 2002 to that in 2006?
Your answer should be very brief. 0.99. What is the ratio of the Life expectancy(years) in Armenia in 2002 to that in 2006?
Your answer should be compact. 0.98. What is the ratio of the Life expectancy(years) in Middle East & North Africa (developing only) in 2002 to that in 2007?
Make the answer very short. 0.98. What is the ratio of the Life expectancy(years) of Armenia in 2002 to that in 2007?
Offer a terse response. 0.98. What is the ratio of the Life expectancy(years) in Armenia in 2003 to that in 2004?
Your answer should be very brief. 1. What is the ratio of the Life expectancy(years) of Sri Lanka in 2003 to that in 2004?
Keep it short and to the point. 1. What is the ratio of the Life expectancy(years) in Armenia in 2003 to that in 2005?
Ensure brevity in your answer.  0.99. What is the ratio of the Life expectancy(years) in Sri Lanka in 2003 to that in 2005?
Your answer should be compact. 1. What is the ratio of the Life expectancy(years) of Armenia in 2003 to that in 2006?
Provide a short and direct response. 0.99. What is the ratio of the Life expectancy(years) of Armenia in 2003 to that in 2007?
Your answer should be very brief. 0.98. What is the ratio of the Life expectancy(years) in Sri Lanka in 2003 to that in 2007?
Offer a terse response. 1. What is the ratio of the Life expectancy(years) of Middle East & North Africa (developing only) in 2004 to that in 2005?
Keep it short and to the point. 1. What is the ratio of the Life expectancy(years) of Armenia in 2004 to that in 2005?
Your answer should be compact. 1. What is the ratio of the Life expectancy(years) in Sri Lanka in 2004 to that in 2005?
Make the answer very short. 1. What is the ratio of the Life expectancy(years) of Middle East & North Africa (developing only) in 2004 to that in 2006?
Your answer should be very brief. 0.99. What is the ratio of the Life expectancy(years) in Middle East & North Africa (developing only) in 2004 to that in 2007?
Ensure brevity in your answer.  0.99. What is the ratio of the Life expectancy(years) in Armenia in 2004 to that in 2007?
Make the answer very short. 0.99. What is the ratio of the Life expectancy(years) of Sri Lanka in 2004 to that in 2007?
Offer a very short reply. 1. What is the ratio of the Life expectancy(years) of Armenia in 2005 to that in 2006?
Make the answer very short. 1. What is the ratio of the Life expectancy(years) of Sri Lanka in 2005 to that in 2007?
Keep it short and to the point. 1. What is the ratio of the Life expectancy(years) in Middle East & North Africa (developing only) in 2006 to that in 2007?
Your answer should be compact. 1. What is the difference between the highest and the second highest Life expectancy(years) of Middle East & North Africa (developing only)?
Your answer should be compact. 0.26. What is the difference between the highest and the second highest Life expectancy(years) in Armenia?
Offer a terse response. 0.24. What is the difference between the highest and the second highest Life expectancy(years) of Sri Lanka?
Provide a succinct answer. 0.05. What is the difference between the highest and the lowest Life expectancy(years) in Middle East & North Africa (developing only)?
Your answer should be very brief. 1.93. What is the difference between the highest and the lowest Life expectancy(years) of Armenia?
Your answer should be very brief. 2.53. What is the difference between the highest and the lowest Life expectancy(years) of Sri Lanka?
Offer a very short reply. 2.15. 